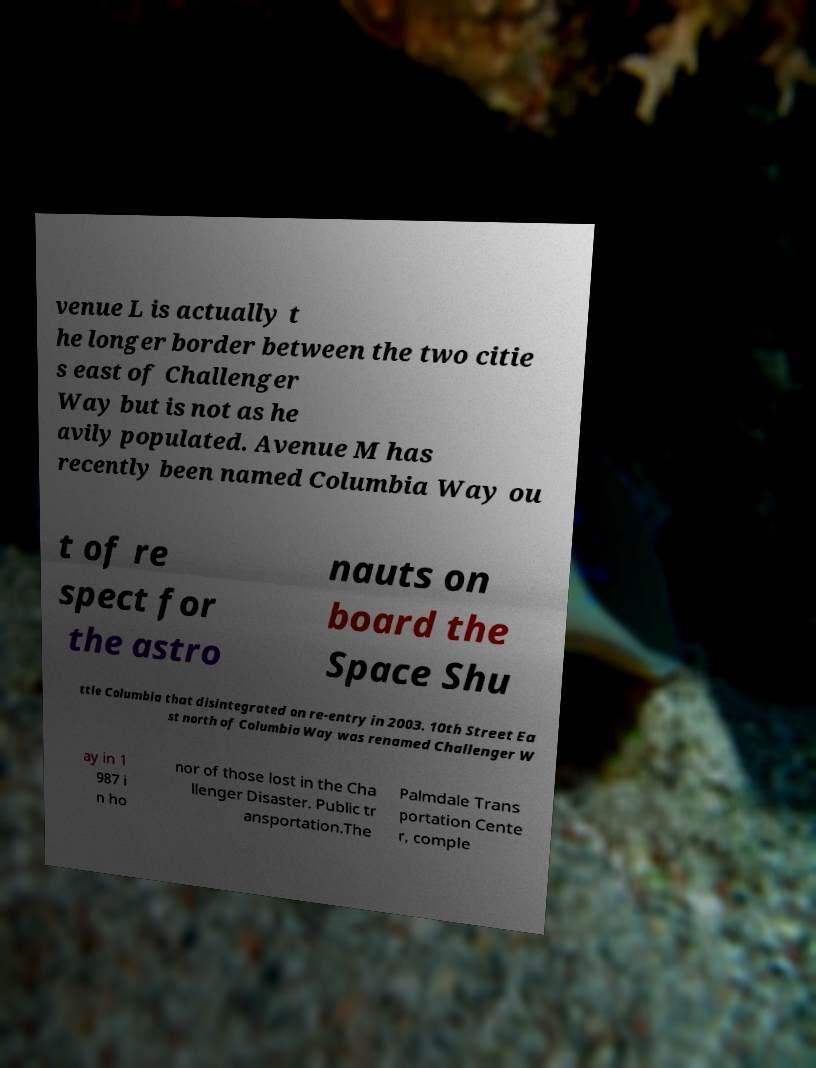Please identify and transcribe the text found in this image. venue L is actually t he longer border between the two citie s east of Challenger Way but is not as he avily populated. Avenue M has recently been named Columbia Way ou t of re spect for the astro nauts on board the Space Shu ttle Columbia that disintegrated on re-entry in 2003. 10th Street Ea st north of Columbia Way was renamed Challenger W ay in 1 987 i n ho nor of those lost in the Cha llenger Disaster. Public tr ansportation.The Palmdale Trans portation Cente r, comple 